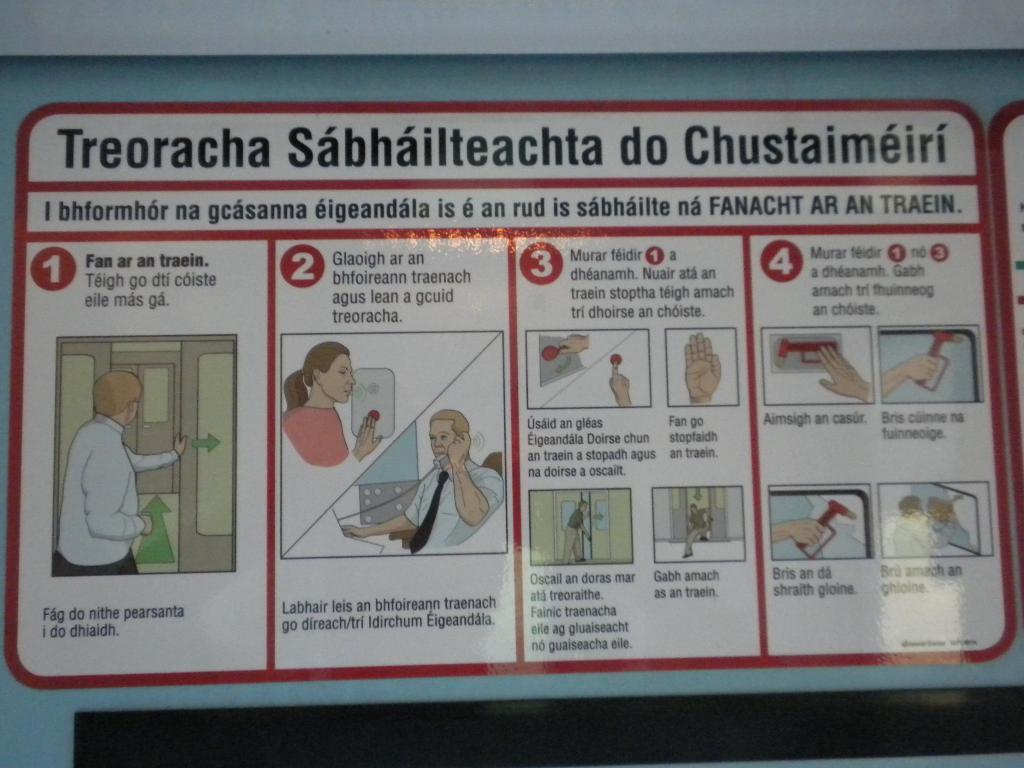Could you give a brief overview of what you see in this image? In this picture I can see a wall with text and few cartoon pictures. 